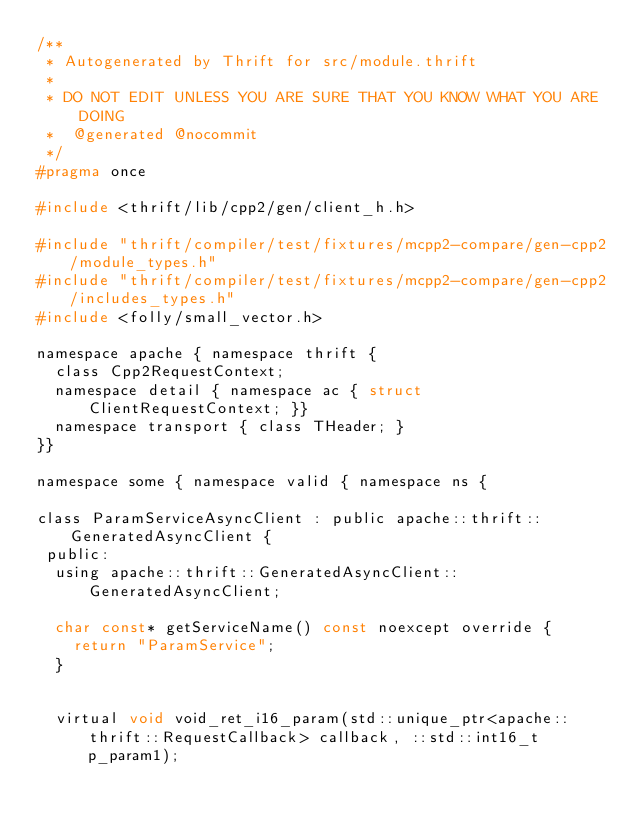Convert code to text. <code><loc_0><loc_0><loc_500><loc_500><_C_>/**
 * Autogenerated by Thrift for src/module.thrift
 *
 * DO NOT EDIT UNLESS YOU ARE SURE THAT YOU KNOW WHAT YOU ARE DOING
 *  @generated @nocommit
 */
#pragma once

#include <thrift/lib/cpp2/gen/client_h.h>

#include "thrift/compiler/test/fixtures/mcpp2-compare/gen-cpp2/module_types.h"
#include "thrift/compiler/test/fixtures/mcpp2-compare/gen-cpp2/includes_types.h"
#include <folly/small_vector.h>

namespace apache { namespace thrift {
  class Cpp2RequestContext;
  namespace detail { namespace ac { struct ClientRequestContext; }}
  namespace transport { class THeader; }
}}

namespace some { namespace valid { namespace ns {

class ParamServiceAsyncClient : public apache::thrift::GeneratedAsyncClient {
 public:
  using apache::thrift::GeneratedAsyncClient::GeneratedAsyncClient;

  char const* getServiceName() const noexcept override {
    return "ParamService";
  }


  virtual void void_ret_i16_param(std::unique_ptr<apache::thrift::RequestCallback> callback, ::std::int16_t p_param1);</code> 